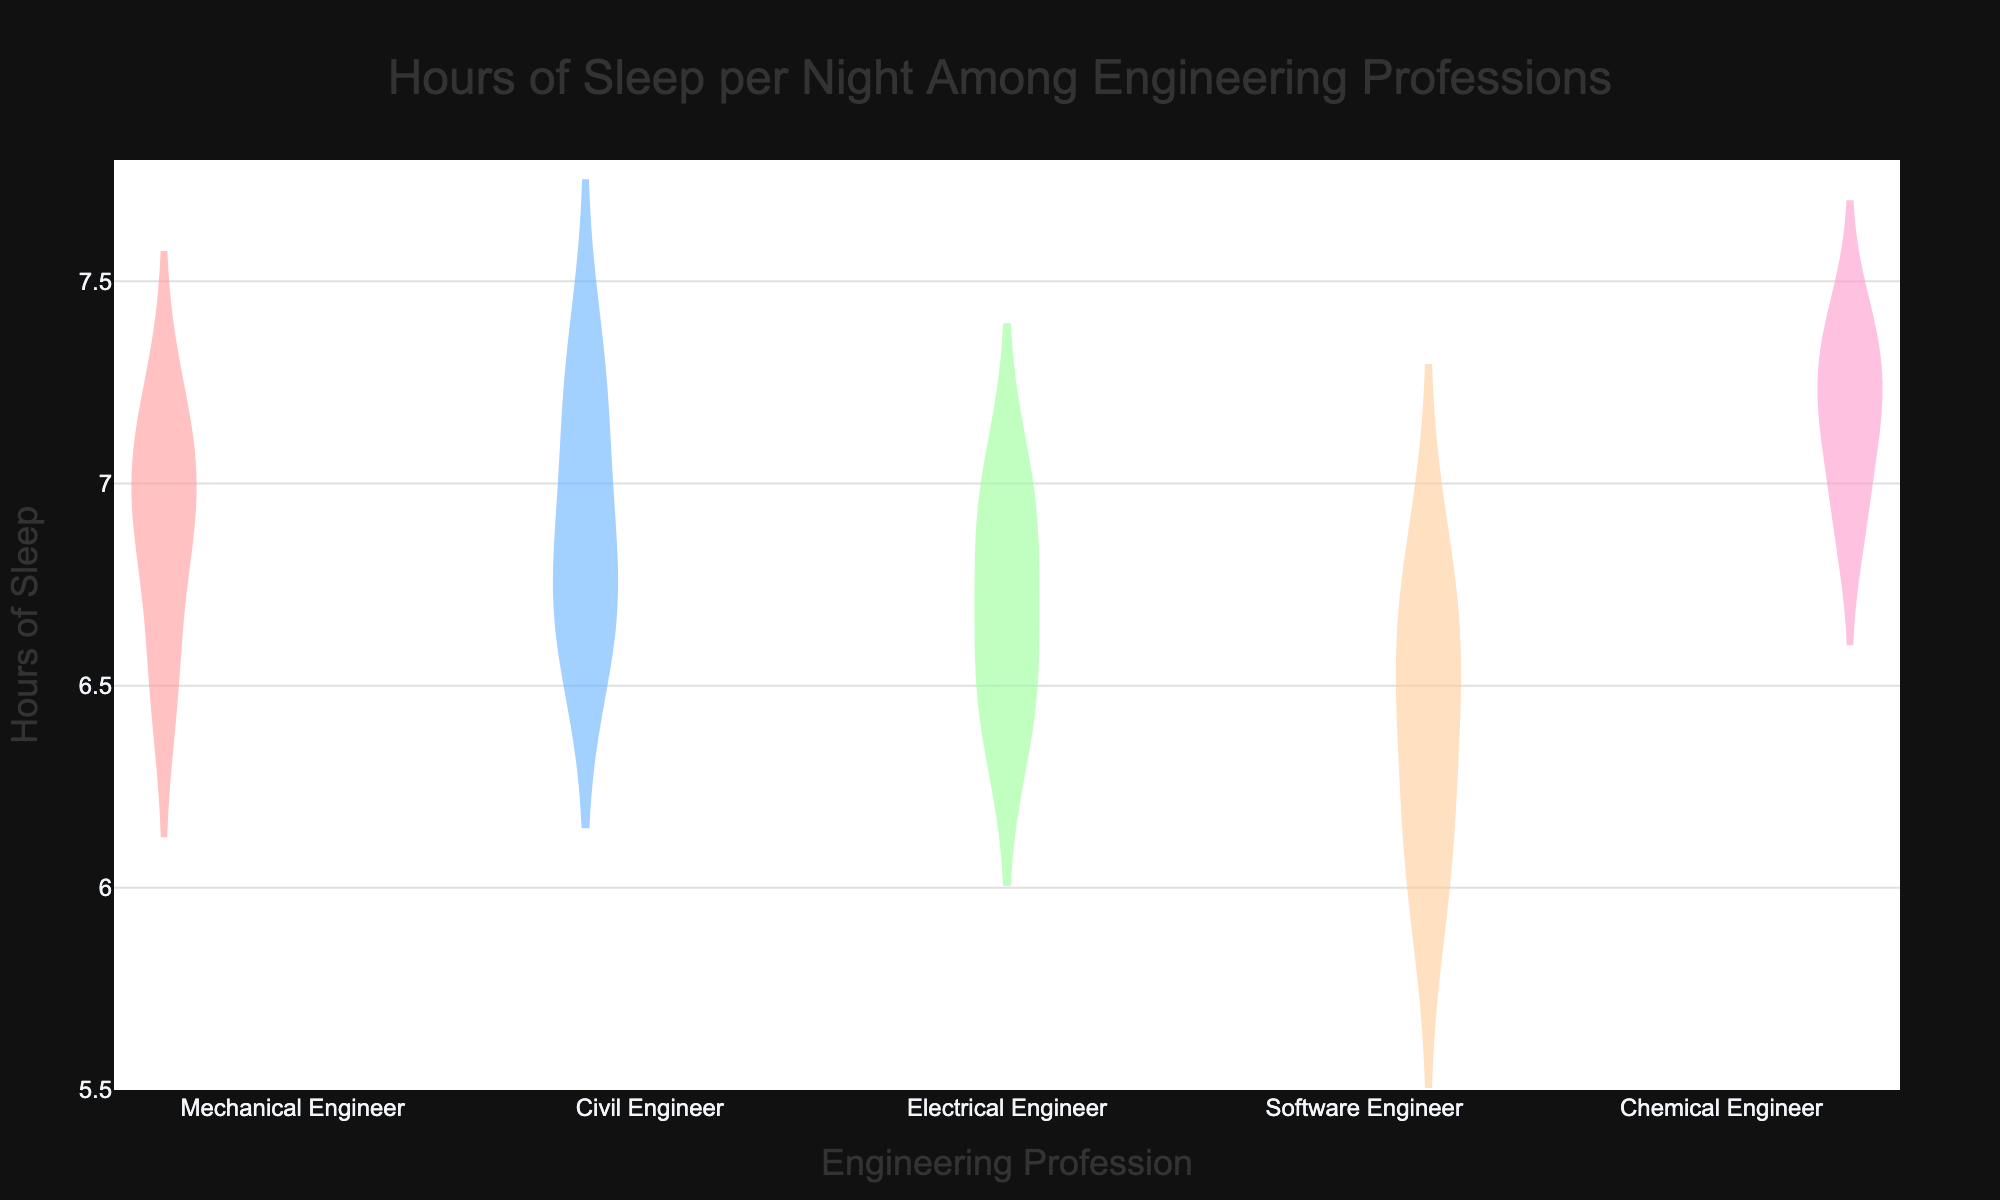What is the title of the chart? The title of the chart is located at the top and is typically in larger font, making it easy to identify.
Answer: Hours of Sleep per Night Among Engineering Professions How many different engineering professions are compared in the chart? By counting the unique categories along the x-axis, which represent different engineering professions, one can determine the number of groups.
Answer: 5 Which profession has the highest average hours of sleep? Observing the meanline indicators (usually a horizontal bar within each violin plot) helps to identify which profession has the highest average hours of sleep.
Answer: Chemical Engineer What is the range of hours of sleep for Electrical Engineers? Each violin plot visualizes the distribution of data points. For Electrical Engineers, the range can be identified by looking at the topmost and bottommost parts of the plot.
Answer: 6.4 to 7.0 Which profession shows the widest spread in hours of sleep? The width of the violin plot at different points indicates the spread of data. The profession with the widest plot generally has the widest spread.
Answer: Chemical Engineer How does the median value of Mechanical Engineers compare to that of Civil Engineers? The median is usually indicated by the thick line within the box plot component inside the violin. Comparing Mechanical Engineers and Civil Engineers involves checking which profession’s median line is higher.
Answer: Mechanical Engineers' median is slightly higher Which profession has the least variability in hours of sleep? Variability can be assessed by looking at the overall width and distribution shape of the violin plot. The narrowest and most compact plot indicates the least variability.
Answer: Software Engineer What is the interquartile range (IQR) for Chemical Engineers? The interquartile range is found between the lower quartile (25th percentile) and the upper quartile (75th percentile), which are usually marked by the edges of the box in the box plot component within the violin.
Answer: 7.1 to 7.3 Are there any professions with overlapping ranges of hours of sleep? Overlapping ranges can be identified by seeing if the violin plots of different professions share any common vertical space on the y-axis.
Answer: Yes, all professions show some overlap 